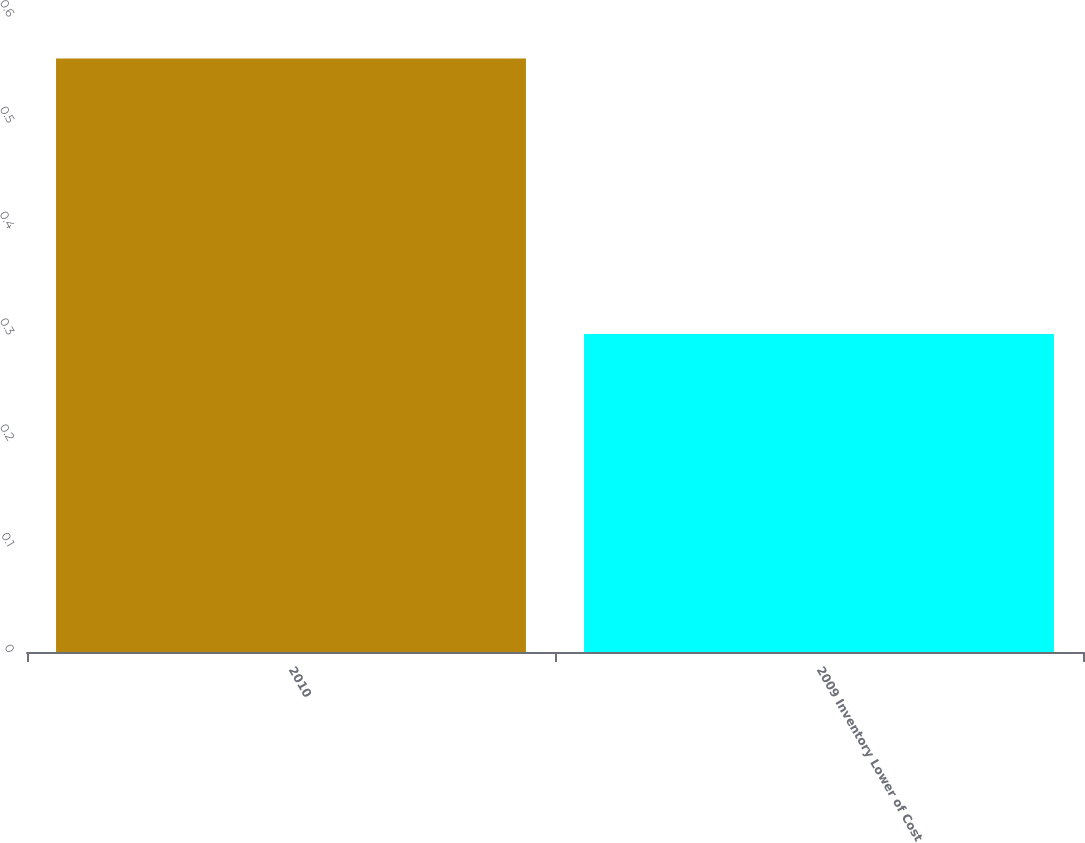Convert chart to OTSL. <chart><loc_0><loc_0><loc_500><loc_500><bar_chart><fcel>2010<fcel>2009 Inventory Lower of Cost<nl><fcel>0.56<fcel>0.3<nl></chart> 